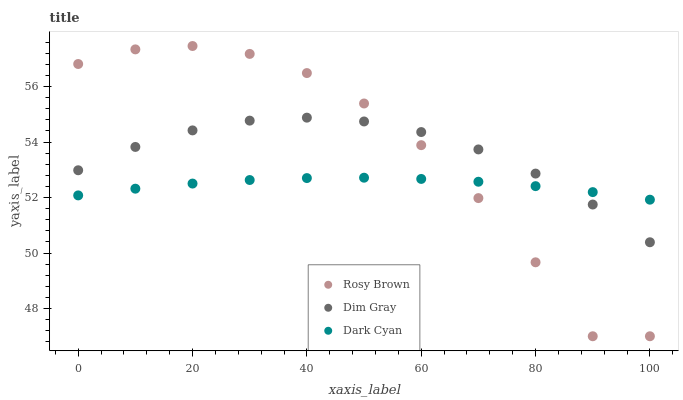Does Dark Cyan have the minimum area under the curve?
Answer yes or no. Yes. Does Rosy Brown have the maximum area under the curve?
Answer yes or no. Yes. Does Dim Gray have the minimum area under the curve?
Answer yes or no. No. Does Dim Gray have the maximum area under the curve?
Answer yes or no. No. Is Dark Cyan the smoothest?
Answer yes or no. Yes. Is Rosy Brown the roughest?
Answer yes or no. Yes. Is Dim Gray the smoothest?
Answer yes or no. No. Is Dim Gray the roughest?
Answer yes or no. No. Does Rosy Brown have the lowest value?
Answer yes or no. Yes. Does Dim Gray have the lowest value?
Answer yes or no. No. Does Rosy Brown have the highest value?
Answer yes or no. Yes. Does Dim Gray have the highest value?
Answer yes or no. No. Does Rosy Brown intersect Dim Gray?
Answer yes or no. Yes. Is Rosy Brown less than Dim Gray?
Answer yes or no. No. Is Rosy Brown greater than Dim Gray?
Answer yes or no. No. 